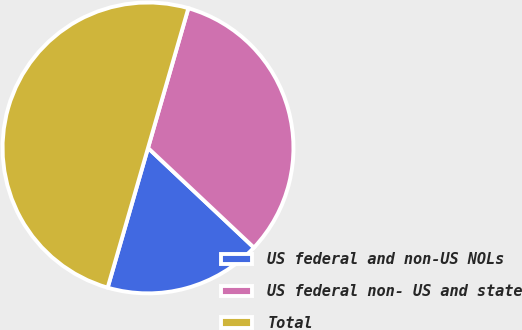Convert chart. <chart><loc_0><loc_0><loc_500><loc_500><pie_chart><fcel>US federal and non-US NOLs<fcel>US federal non- US and state<fcel>Total<nl><fcel>17.46%<fcel>32.54%<fcel>50.0%<nl></chart> 